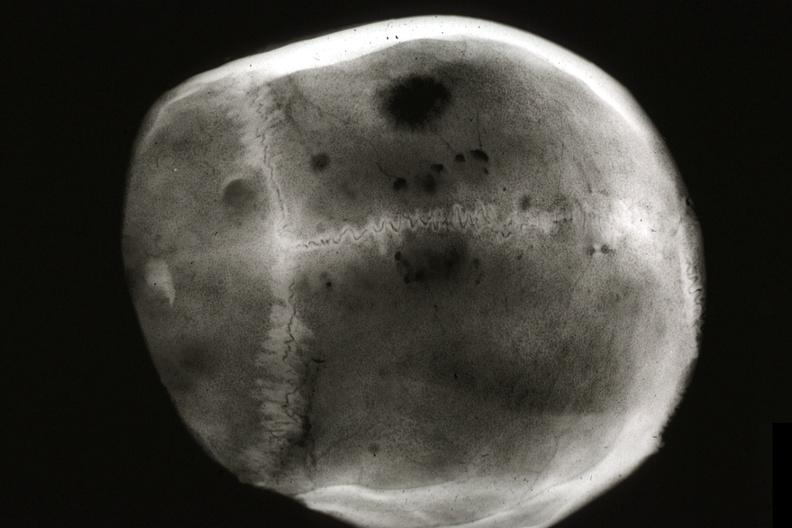s metastatic carcinoma x-ray present?
Answer the question using a single word or phrase. Yes 